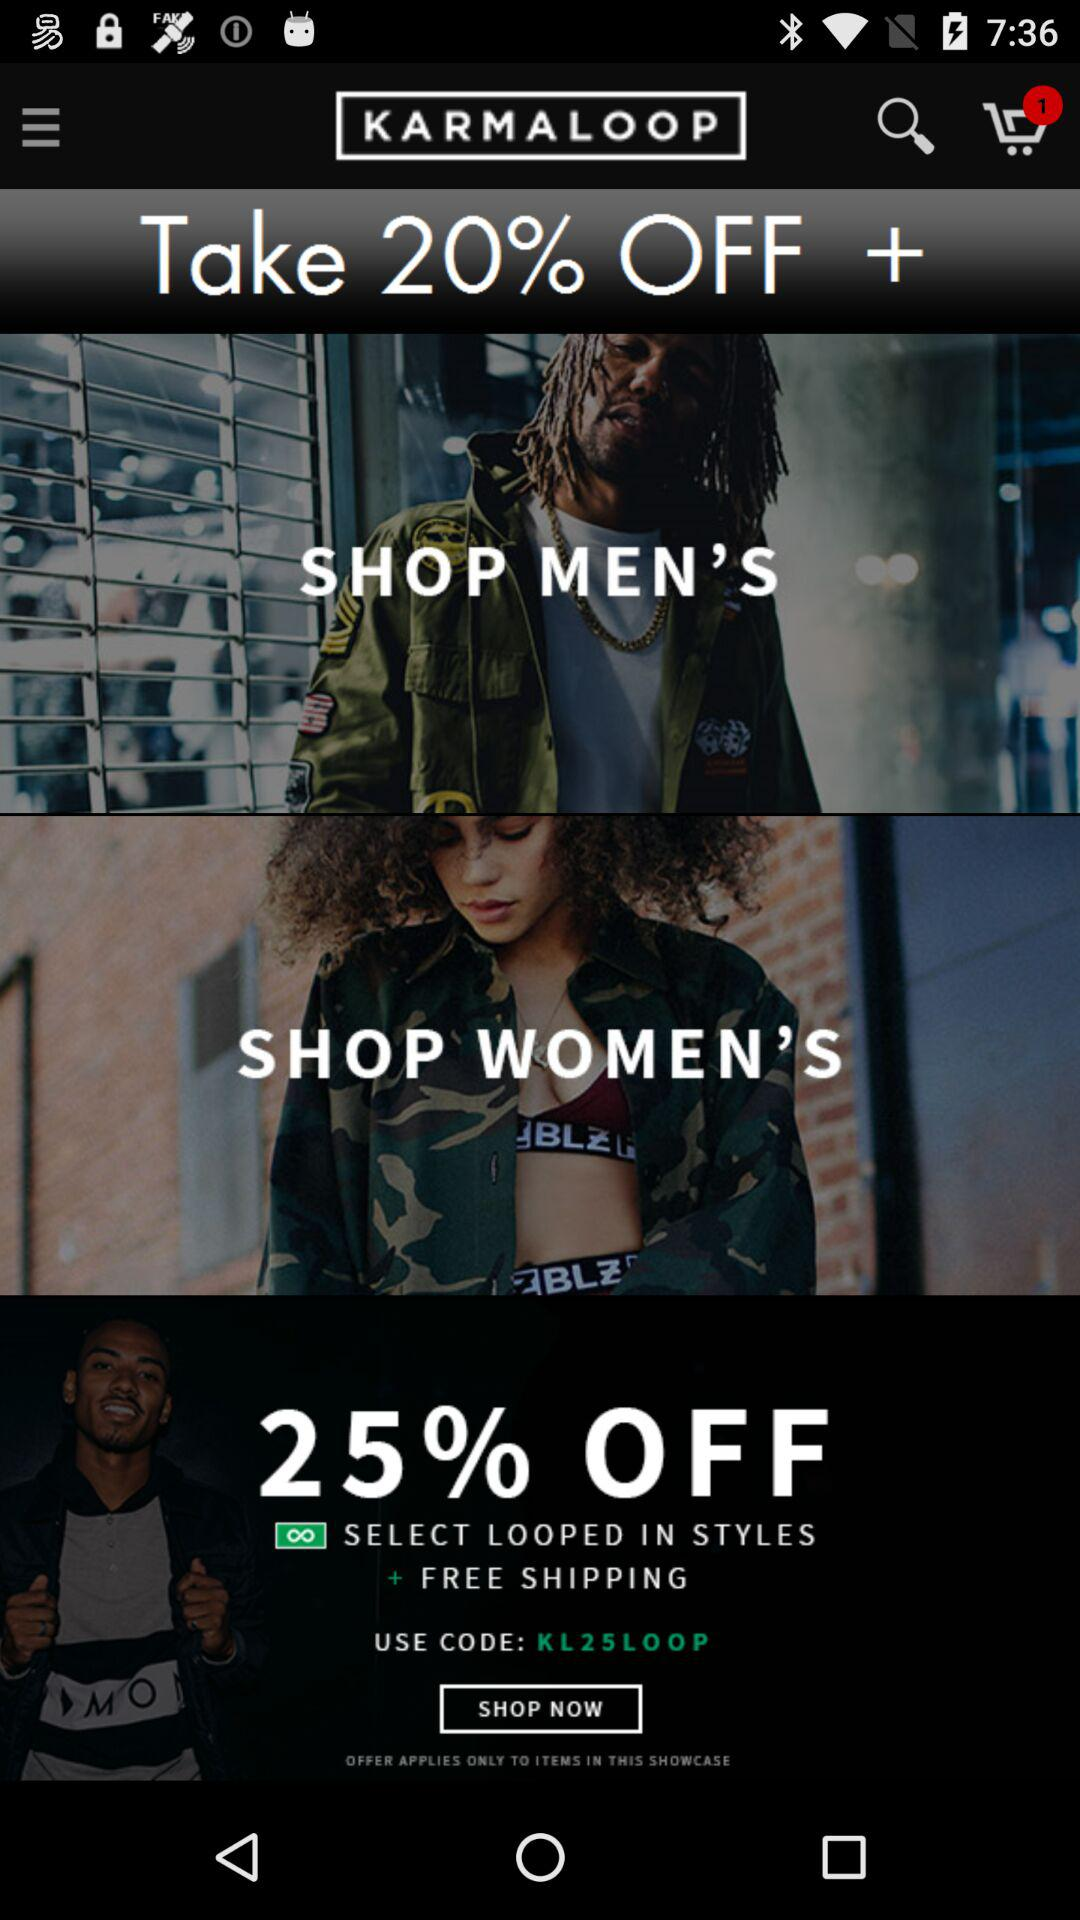What code can be used in the application? The code is "KL25LOOP". 